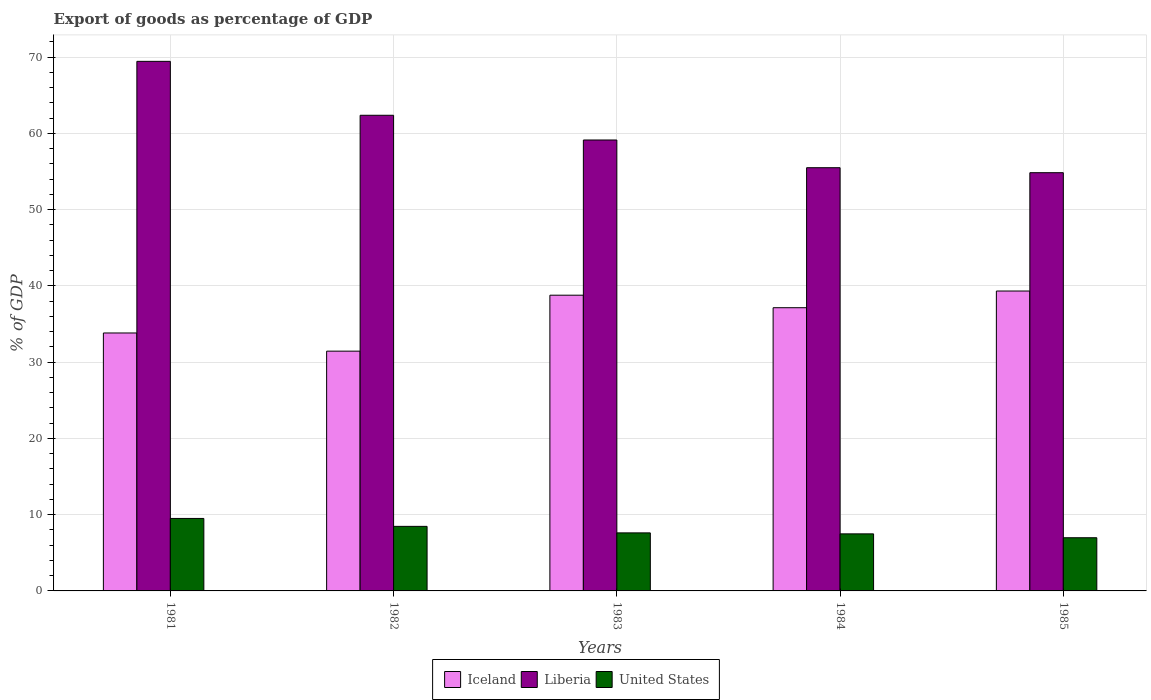How many different coloured bars are there?
Give a very brief answer. 3. What is the export of goods as percentage of GDP in United States in 1984?
Your response must be concise. 7.48. Across all years, what is the maximum export of goods as percentage of GDP in United States?
Your answer should be compact. 9.51. Across all years, what is the minimum export of goods as percentage of GDP in Iceland?
Keep it short and to the point. 31.45. In which year was the export of goods as percentage of GDP in Iceland maximum?
Your answer should be very brief. 1985. What is the total export of goods as percentage of GDP in Liberia in the graph?
Your answer should be very brief. 301.37. What is the difference between the export of goods as percentage of GDP in Iceland in 1984 and that in 1985?
Provide a short and direct response. -2.19. What is the difference between the export of goods as percentage of GDP in United States in 1981 and the export of goods as percentage of GDP in Liberia in 1984?
Offer a terse response. -46. What is the average export of goods as percentage of GDP in Liberia per year?
Keep it short and to the point. 60.27. In the year 1981, what is the difference between the export of goods as percentage of GDP in United States and export of goods as percentage of GDP in Liberia?
Keep it short and to the point. -59.96. In how many years, is the export of goods as percentage of GDP in Liberia greater than 32 %?
Offer a terse response. 5. What is the ratio of the export of goods as percentage of GDP in United States in 1984 to that in 1985?
Give a very brief answer. 1.07. Is the export of goods as percentage of GDP in United States in 1984 less than that in 1985?
Your response must be concise. No. What is the difference between the highest and the second highest export of goods as percentage of GDP in United States?
Your response must be concise. 1.04. What is the difference between the highest and the lowest export of goods as percentage of GDP in United States?
Offer a very short reply. 2.53. What does the 1st bar from the left in 1981 represents?
Provide a short and direct response. Iceland. What does the 2nd bar from the right in 1983 represents?
Ensure brevity in your answer.  Liberia. Is it the case that in every year, the sum of the export of goods as percentage of GDP in United States and export of goods as percentage of GDP in Liberia is greater than the export of goods as percentage of GDP in Iceland?
Your answer should be compact. Yes. Does the graph contain any zero values?
Offer a very short reply. No. What is the title of the graph?
Offer a very short reply. Export of goods as percentage of GDP. What is the label or title of the X-axis?
Your response must be concise. Years. What is the label or title of the Y-axis?
Your answer should be compact. % of GDP. What is the % of GDP of Iceland in 1981?
Your answer should be very brief. 33.83. What is the % of GDP of Liberia in 1981?
Provide a short and direct response. 69.46. What is the % of GDP of United States in 1981?
Offer a very short reply. 9.51. What is the % of GDP of Iceland in 1982?
Ensure brevity in your answer.  31.45. What is the % of GDP of Liberia in 1982?
Your answer should be very brief. 62.39. What is the % of GDP in United States in 1982?
Your answer should be very brief. 8.47. What is the % of GDP in Iceland in 1983?
Your response must be concise. 38.79. What is the % of GDP in Liberia in 1983?
Provide a succinct answer. 59.15. What is the % of GDP of United States in 1983?
Provide a short and direct response. 7.61. What is the % of GDP of Iceland in 1984?
Your answer should be compact. 37.15. What is the % of GDP in Liberia in 1984?
Provide a succinct answer. 55.51. What is the % of GDP of United States in 1984?
Provide a short and direct response. 7.48. What is the % of GDP of Iceland in 1985?
Provide a short and direct response. 39.34. What is the % of GDP of Liberia in 1985?
Offer a very short reply. 54.86. What is the % of GDP in United States in 1985?
Your response must be concise. 6.98. Across all years, what is the maximum % of GDP in Iceland?
Your answer should be compact. 39.34. Across all years, what is the maximum % of GDP in Liberia?
Keep it short and to the point. 69.46. Across all years, what is the maximum % of GDP in United States?
Your answer should be very brief. 9.51. Across all years, what is the minimum % of GDP of Iceland?
Your answer should be compact. 31.45. Across all years, what is the minimum % of GDP in Liberia?
Ensure brevity in your answer.  54.86. Across all years, what is the minimum % of GDP in United States?
Ensure brevity in your answer.  6.98. What is the total % of GDP in Iceland in the graph?
Offer a terse response. 180.56. What is the total % of GDP of Liberia in the graph?
Provide a succinct answer. 301.37. What is the total % of GDP in United States in the graph?
Provide a short and direct response. 40.05. What is the difference between the % of GDP of Iceland in 1981 and that in 1982?
Ensure brevity in your answer.  2.38. What is the difference between the % of GDP in Liberia in 1981 and that in 1982?
Your answer should be very brief. 7.07. What is the difference between the % of GDP in United States in 1981 and that in 1982?
Offer a terse response. 1.04. What is the difference between the % of GDP in Iceland in 1981 and that in 1983?
Provide a succinct answer. -4.96. What is the difference between the % of GDP of Liberia in 1981 and that in 1983?
Provide a succinct answer. 10.31. What is the difference between the % of GDP of United States in 1981 and that in 1983?
Provide a short and direct response. 1.89. What is the difference between the % of GDP in Iceland in 1981 and that in 1984?
Your answer should be compact. -3.31. What is the difference between the % of GDP of Liberia in 1981 and that in 1984?
Offer a very short reply. 13.95. What is the difference between the % of GDP of United States in 1981 and that in 1984?
Offer a very short reply. 2.02. What is the difference between the % of GDP in Iceland in 1981 and that in 1985?
Ensure brevity in your answer.  -5.5. What is the difference between the % of GDP in Liberia in 1981 and that in 1985?
Give a very brief answer. 14.6. What is the difference between the % of GDP in United States in 1981 and that in 1985?
Give a very brief answer. 2.53. What is the difference between the % of GDP in Iceland in 1982 and that in 1983?
Your answer should be compact. -7.34. What is the difference between the % of GDP of Liberia in 1982 and that in 1983?
Give a very brief answer. 3.24. What is the difference between the % of GDP in United States in 1982 and that in 1983?
Offer a terse response. 0.85. What is the difference between the % of GDP of Iceland in 1982 and that in 1984?
Offer a terse response. -5.7. What is the difference between the % of GDP in Liberia in 1982 and that in 1984?
Provide a short and direct response. 6.88. What is the difference between the % of GDP of United States in 1982 and that in 1984?
Give a very brief answer. 0.98. What is the difference between the % of GDP of Iceland in 1982 and that in 1985?
Ensure brevity in your answer.  -7.89. What is the difference between the % of GDP of Liberia in 1982 and that in 1985?
Give a very brief answer. 7.53. What is the difference between the % of GDP of United States in 1982 and that in 1985?
Offer a terse response. 1.49. What is the difference between the % of GDP in Iceland in 1983 and that in 1984?
Give a very brief answer. 1.64. What is the difference between the % of GDP of Liberia in 1983 and that in 1984?
Offer a very short reply. 3.64. What is the difference between the % of GDP of United States in 1983 and that in 1984?
Provide a succinct answer. 0.13. What is the difference between the % of GDP in Iceland in 1983 and that in 1985?
Provide a short and direct response. -0.55. What is the difference between the % of GDP in Liberia in 1983 and that in 1985?
Keep it short and to the point. 4.29. What is the difference between the % of GDP in United States in 1983 and that in 1985?
Keep it short and to the point. 0.64. What is the difference between the % of GDP of Iceland in 1984 and that in 1985?
Keep it short and to the point. -2.19. What is the difference between the % of GDP in Liberia in 1984 and that in 1985?
Offer a very short reply. 0.65. What is the difference between the % of GDP of United States in 1984 and that in 1985?
Your answer should be compact. 0.51. What is the difference between the % of GDP in Iceland in 1981 and the % of GDP in Liberia in 1982?
Make the answer very short. -28.56. What is the difference between the % of GDP of Iceland in 1981 and the % of GDP of United States in 1982?
Make the answer very short. 25.37. What is the difference between the % of GDP in Liberia in 1981 and the % of GDP in United States in 1982?
Your answer should be very brief. 60.99. What is the difference between the % of GDP of Iceland in 1981 and the % of GDP of Liberia in 1983?
Keep it short and to the point. -25.31. What is the difference between the % of GDP of Iceland in 1981 and the % of GDP of United States in 1983?
Ensure brevity in your answer.  26.22. What is the difference between the % of GDP in Liberia in 1981 and the % of GDP in United States in 1983?
Offer a very short reply. 61.85. What is the difference between the % of GDP in Iceland in 1981 and the % of GDP in Liberia in 1984?
Provide a succinct answer. -21.68. What is the difference between the % of GDP of Iceland in 1981 and the % of GDP of United States in 1984?
Offer a terse response. 26.35. What is the difference between the % of GDP in Liberia in 1981 and the % of GDP in United States in 1984?
Your answer should be very brief. 61.98. What is the difference between the % of GDP of Iceland in 1981 and the % of GDP of Liberia in 1985?
Provide a short and direct response. -21.02. What is the difference between the % of GDP of Iceland in 1981 and the % of GDP of United States in 1985?
Ensure brevity in your answer.  26.86. What is the difference between the % of GDP of Liberia in 1981 and the % of GDP of United States in 1985?
Your response must be concise. 62.49. What is the difference between the % of GDP of Iceland in 1982 and the % of GDP of Liberia in 1983?
Make the answer very short. -27.7. What is the difference between the % of GDP of Iceland in 1982 and the % of GDP of United States in 1983?
Your response must be concise. 23.84. What is the difference between the % of GDP in Liberia in 1982 and the % of GDP in United States in 1983?
Your answer should be very brief. 54.78. What is the difference between the % of GDP in Iceland in 1982 and the % of GDP in Liberia in 1984?
Offer a very short reply. -24.06. What is the difference between the % of GDP in Iceland in 1982 and the % of GDP in United States in 1984?
Ensure brevity in your answer.  23.97. What is the difference between the % of GDP in Liberia in 1982 and the % of GDP in United States in 1984?
Offer a terse response. 54.91. What is the difference between the % of GDP of Iceland in 1982 and the % of GDP of Liberia in 1985?
Your answer should be compact. -23.41. What is the difference between the % of GDP in Iceland in 1982 and the % of GDP in United States in 1985?
Provide a succinct answer. 24.47. What is the difference between the % of GDP of Liberia in 1982 and the % of GDP of United States in 1985?
Your answer should be compact. 55.41. What is the difference between the % of GDP in Iceland in 1983 and the % of GDP in Liberia in 1984?
Make the answer very short. -16.72. What is the difference between the % of GDP in Iceland in 1983 and the % of GDP in United States in 1984?
Provide a succinct answer. 31.31. What is the difference between the % of GDP in Liberia in 1983 and the % of GDP in United States in 1984?
Ensure brevity in your answer.  51.66. What is the difference between the % of GDP of Iceland in 1983 and the % of GDP of Liberia in 1985?
Keep it short and to the point. -16.07. What is the difference between the % of GDP of Iceland in 1983 and the % of GDP of United States in 1985?
Make the answer very short. 31.81. What is the difference between the % of GDP in Liberia in 1983 and the % of GDP in United States in 1985?
Provide a short and direct response. 52.17. What is the difference between the % of GDP of Iceland in 1984 and the % of GDP of Liberia in 1985?
Offer a terse response. -17.71. What is the difference between the % of GDP of Iceland in 1984 and the % of GDP of United States in 1985?
Provide a succinct answer. 30.17. What is the difference between the % of GDP in Liberia in 1984 and the % of GDP in United States in 1985?
Make the answer very short. 48.54. What is the average % of GDP in Iceland per year?
Your answer should be very brief. 36.11. What is the average % of GDP of Liberia per year?
Offer a terse response. 60.27. What is the average % of GDP of United States per year?
Your answer should be compact. 8.01. In the year 1981, what is the difference between the % of GDP in Iceland and % of GDP in Liberia?
Offer a terse response. -35.63. In the year 1981, what is the difference between the % of GDP in Iceland and % of GDP in United States?
Ensure brevity in your answer.  24.33. In the year 1981, what is the difference between the % of GDP of Liberia and % of GDP of United States?
Make the answer very short. 59.96. In the year 1982, what is the difference between the % of GDP in Iceland and % of GDP in Liberia?
Provide a succinct answer. -30.94. In the year 1982, what is the difference between the % of GDP in Iceland and % of GDP in United States?
Your answer should be compact. 22.98. In the year 1982, what is the difference between the % of GDP in Liberia and % of GDP in United States?
Keep it short and to the point. 53.92. In the year 1983, what is the difference between the % of GDP of Iceland and % of GDP of Liberia?
Ensure brevity in your answer.  -20.36. In the year 1983, what is the difference between the % of GDP of Iceland and % of GDP of United States?
Provide a short and direct response. 31.18. In the year 1983, what is the difference between the % of GDP in Liberia and % of GDP in United States?
Keep it short and to the point. 51.53. In the year 1984, what is the difference between the % of GDP of Iceland and % of GDP of Liberia?
Keep it short and to the point. -18.36. In the year 1984, what is the difference between the % of GDP of Iceland and % of GDP of United States?
Make the answer very short. 29.66. In the year 1984, what is the difference between the % of GDP in Liberia and % of GDP in United States?
Make the answer very short. 48.03. In the year 1985, what is the difference between the % of GDP of Iceland and % of GDP of Liberia?
Your response must be concise. -15.52. In the year 1985, what is the difference between the % of GDP of Iceland and % of GDP of United States?
Offer a very short reply. 32.36. In the year 1985, what is the difference between the % of GDP in Liberia and % of GDP in United States?
Your response must be concise. 47.88. What is the ratio of the % of GDP in Iceland in 1981 to that in 1982?
Keep it short and to the point. 1.08. What is the ratio of the % of GDP in Liberia in 1981 to that in 1982?
Your answer should be compact. 1.11. What is the ratio of the % of GDP in United States in 1981 to that in 1982?
Offer a very short reply. 1.12. What is the ratio of the % of GDP in Iceland in 1981 to that in 1983?
Your answer should be very brief. 0.87. What is the ratio of the % of GDP in Liberia in 1981 to that in 1983?
Your response must be concise. 1.17. What is the ratio of the % of GDP in United States in 1981 to that in 1983?
Your answer should be very brief. 1.25. What is the ratio of the % of GDP in Iceland in 1981 to that in 1984?
Offer a terse response. 0.91. What is the ratio of the % of GDP in Liberia in 1981 to that in 1984?
Your response must be concise. 1.25. What is the ratio of the % of GDP of United States in 1981 to that in 1984?
Provide a short and direct response. 1.27. What is the ratio of the % of GDP in Iceland in 1981 to that in 1985?
Offer a terse response. 0.86. What is the ratio of the % of GDP in Liberia in 1981 to that in 1985?
Keep it short and to the point. 1.27. What is the ratio of the % of GDP in United States in 1981 to that in 1985?
Offer a very short reply. 1.36. What is the ratio of the % of GDP in Iceland in 1982 to that in 1983?
Provide a succinct answer. 0.81. What is the ratio of the % of GDP in Liberia in 1982 to that in 1983?
Give a very brief answer. 1.05. What is the ratio of the % of GDP of United States in 1982 to that in 1983?
Give a very brief answer. 1.11. What is the ratio of the % of GDP in Iceland in 1982 to that in 1984?
Your answer should be compact. 0.85. What is the ratio of the % of GDP in Liberia in 1982 to that in 1984?
Give a very brief answer. 1.12. What is the ratio of the % of GDP of United States in 1982 to that in 1984?
Keep it short and to the point. 1.13. What is the ratio of the % of GDP of Iceland in 1982 to that in 1985?
Ensure brevity in your answer.  0.8. What is the ratio of the % of GDP of Liberia in 1982 to that in 1985?
Keep it short and to the point. 1.14. What is the ratio of the % of GDP of United States in 1982 to that in 1985?
Ensure brevity in your answer.  1.21. What is the ratio of the % of GDP of Iceland in 1983 to that in 1984?
Your response must be concise. 1.04. What is the ratio of the % of GDP of Liberia in 1983 to that in 1984?
Offer a very short reply. 1.07. What is the ratio of the % of GDP in United States in 1983 to that in 1984?
Your answer should be compact. 1.02. What is the ratio of the % of GDP in Iceland in 1983 to that in 1985?
Offer a very short reply. 0.99. What is the ratio of the % of GDP in Liberia in 1983 to that in 1985?
Keep it short and to the point. 1.08. What is the ratio of the % of GDP of United States in 1983 to that in 1985?
Offer a very short reply. 1.09. What is the ratio of the % of GDP in Iceland in 1984 to that in 1985?
Provide a succinct answer. 0.94. What is the ratio of the % of GDP of Liberia in 1984 to that in 1985?
Your response must be concise. 1.01. What is the ratio of the % of GDP of United States in 1984 to that in 1985?
Your answer should be very brief. 1.07. What is the difference between the highest and the second highest % of GDP of Iceland?
Make the answer very short. 0.55. What is the difference between the highest and the second highest % of GDP in Liberia?
Keep it short and to the point. 7.07. What is the difference between the highest and the second highest % of GDP in United States?
Make the answer very short. 1.04. What is the difference between the highest and the lowest % of GDP of Iceland?
Ensure brevity in your answer.  7.89. What is the difference between the highest and the lowest % of GDP in Liberia?
Your answer should be very brief. 14.6. What is the difference between the highest and the lowest % of GDP in United States?
Your answer should be very brief. 2.53. 